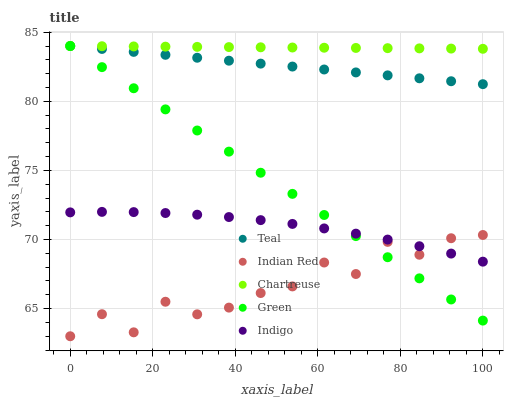Does Indian Red have the minimum area under the curve?
Answer yes or no. Yes. Does Chartreuse have the maximum area under the curve?
Answer yes or no. Yes. Does Green have the minimum area under the curve?
Answer yes or no. No. Does Green have the maximum area under the curve?
Answer yes or no. No. Is Teal the smoothest?
Answer yes or no. Yes. Is Indian Red the roughest?
Answer yes or no. Yes. Is Chartreuse the smoothest?
Answer yes or no. No. Is Chartreuse the roughest?
Answer yes or no. No. Does Indian Red have the lowest value?
Answer yes or no. Yes. Does Green have the lowest value?
Answer yes or no. No. Does Teal have the highest value?
Answer yes or no. Yes. Does Indian Red have the highest value?
Answer yes or no. No. Is Indigo less than Teal?
Answer yes or no. Yes. Is Teal greater than Indigo?
Answer yes or no. Yes. Does Indian Red intersect Indigo?
Answer yes or no. Yes. Is Indian Red less than Indigo?
Answer yes or no. No. Is Indian Red greater than Indigo?
Answer yes or no. No. Does Indigo intersect Teal?
Answer yes or no. No. 